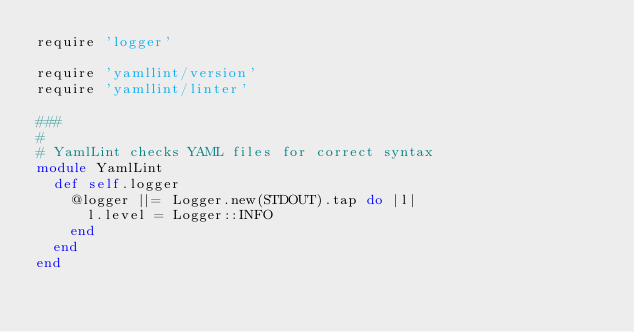Convert code to text. <code><loc_0><loc_0><loc_500><loc_500><_Ruby_>require 'logger'

require 'yamllint/version'
require 'yamllint/linter'

###
#
# YamlLint checks YAML files for correct syntax
module YamlLint
  def self.logger
    @logger ||= Logger.new(STDOUT).tap do |l|
      l.level = Logger::INFO
    end
  end
end
</code> 